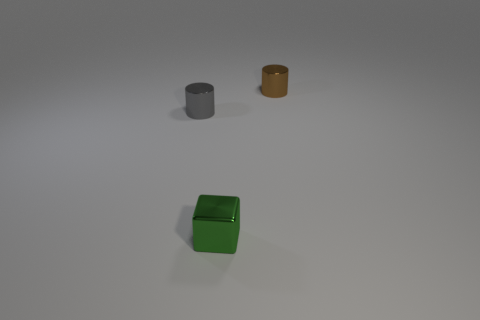How many objects are either tiny objects that are in front of the brown metallic object or tiny metal things?
Your response must be concise. 3. What number of other objects are the same size as the green object?
Make the answer very short. 2. There is a cylinder left of the thing that is behind the object that is on the left side of the green thing; what is its material?
Keep it short and to the point. Metal. How many blocks are brown objects or large cyan objects?
Provide a short and direct response. 0. Is there anything else that is the same shape as the brown metal thing?
Ensure brevity in your answer.  Yes. Is the number of green metal objects right of the tiny metallic cube greater than the number of green blocks that are behind the small brown shiny thing?
Provide a short and direct response. No. How many shiny cylinders are right of the small metallic cylinder that is to the left of the brown object?
Keep it short and to the point. 1. What number of objects are small blue things or small gray things?
Your response must be concise. 1. Do the tiny brown metallic object and the tiny gray object have the same shape?
Your answer should be compact. Yes. What is the material of the small gray thing?
Offer a terse response. Metal. 